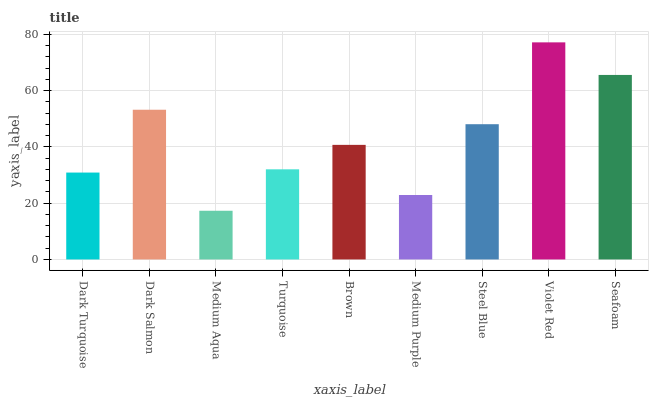Is Medium Aqua the minimum?
Answer yes or no. Yes. Is Violet Red the maximum?
Answer yes or no. Yes. Is Dark Salmon the minimum?
Answer yes or no. No. Is Dark Salmon the maximum?
Answer yes or no. No. Is Dark Salmon greater than Dark Turquoise?
Answer yes or no. Yes. Is Dark Turquoise less than Dark Salmon?
Answer yes or no. Yes. Is Dark Turquoise greater than Dark Salmon?
Answer yes or no. No. Is Dark Salmon less than Dark Turquoise?
Answer yes or no. No. Is Brown the high median?
Answer yes or no. Yes. Is Brown the low median?
Answer yes or no. Yes. Is Seafoam the high median?
Answer yes or no. No. Is Medium Aqua the low median?
Answer yes or no. No. 